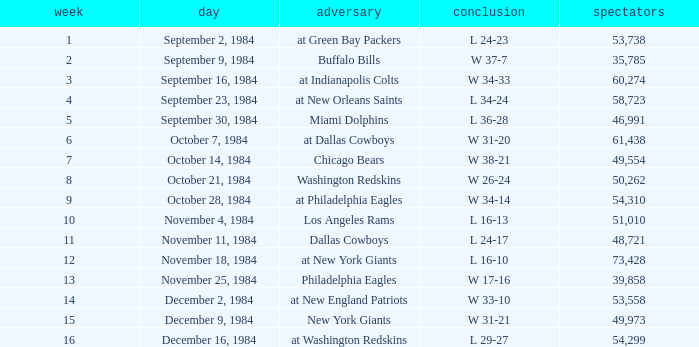Who was the opponent on October 14, 1984? Chicago Bears. 